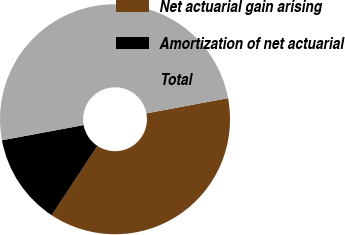<chart> <loc_0><loc_0><loc_500><loc_500><pie_chart><fcel>Net actuarial gain arising<fcel>Amortization of net actuarial<fcel>Total<nl><fcel>37.22%<fcel>12.8%<fcel>49.99%<nl></chart> 